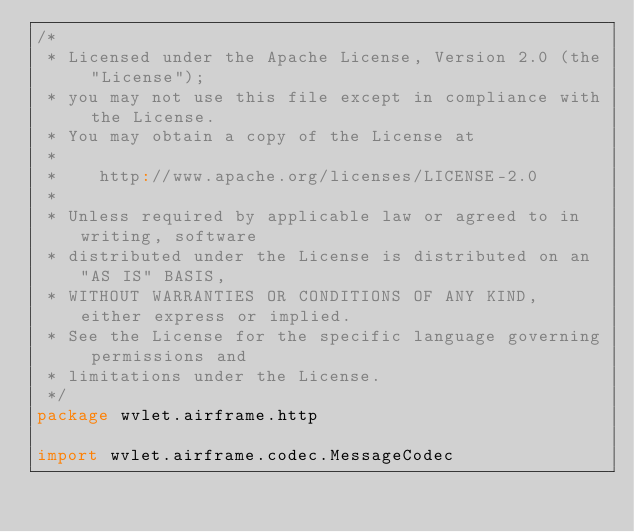Convert code to text. <code><loc_0><loc_0><loc_500><loc_500><_Scala_>/*
 * Licensed under the Apache License, Version 2.0 (the "License");
 * you may not use this file except in compliance with the License.
 * You may obtain a copy of the License at
 *
 *    http://www.apache.org/licenses/LICENSE-2.0
 *
 * Unless required by applicable law or agreed to in writing, software
 * distributed under the License is distributed on an "AS IS" BASIS,
 * WITHOUT WARRANTIES OR CONDITIONS OF ANY KIND, either express or implied.
 * See the License for the specific language governing permissions and
 * limitations under the License.
 */
package wvlet.airframe.http

import wvlet.airframe.codec.MessageCodec</code> 